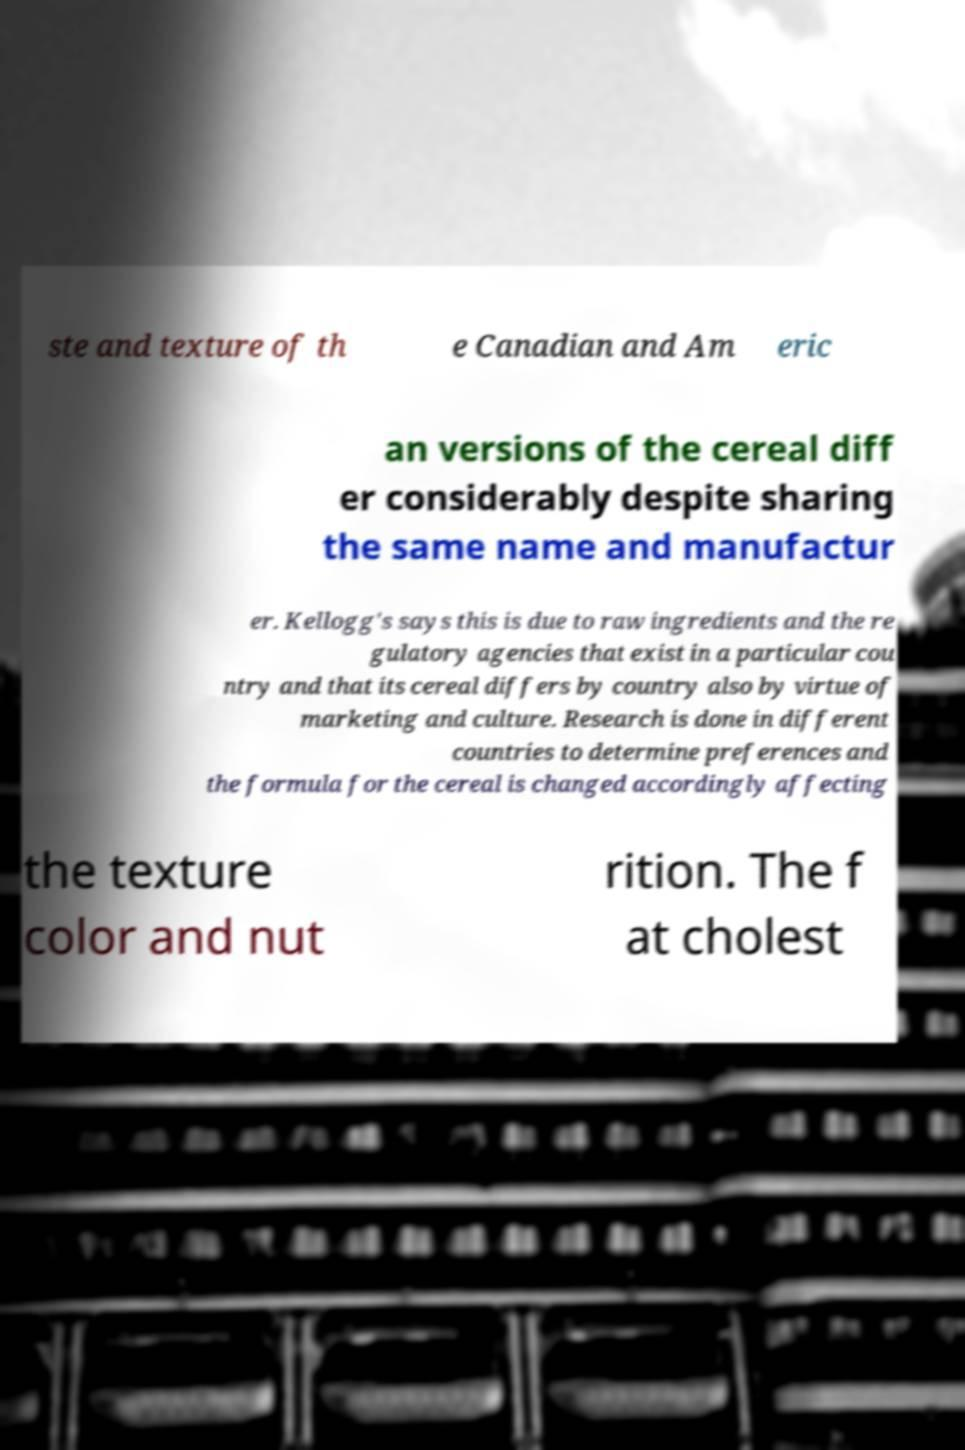What messages or text are displayed in this image? I need them in a readable, typed format. ste and texture of th e Canadian and Am eric an versions of the cereal diff er considerably despite sharing the same name and manufactur er. Kellogg's says this is due to raw ingredients and the re gulatory agencies that exist in a particular cou ntry and that its cereal differs by country also by virtue of marketing and culture. Research is done in different countries to determine preferences and the formula for the cereal is changed accordingly affecting the texture color and nut rition. The f at cholest 